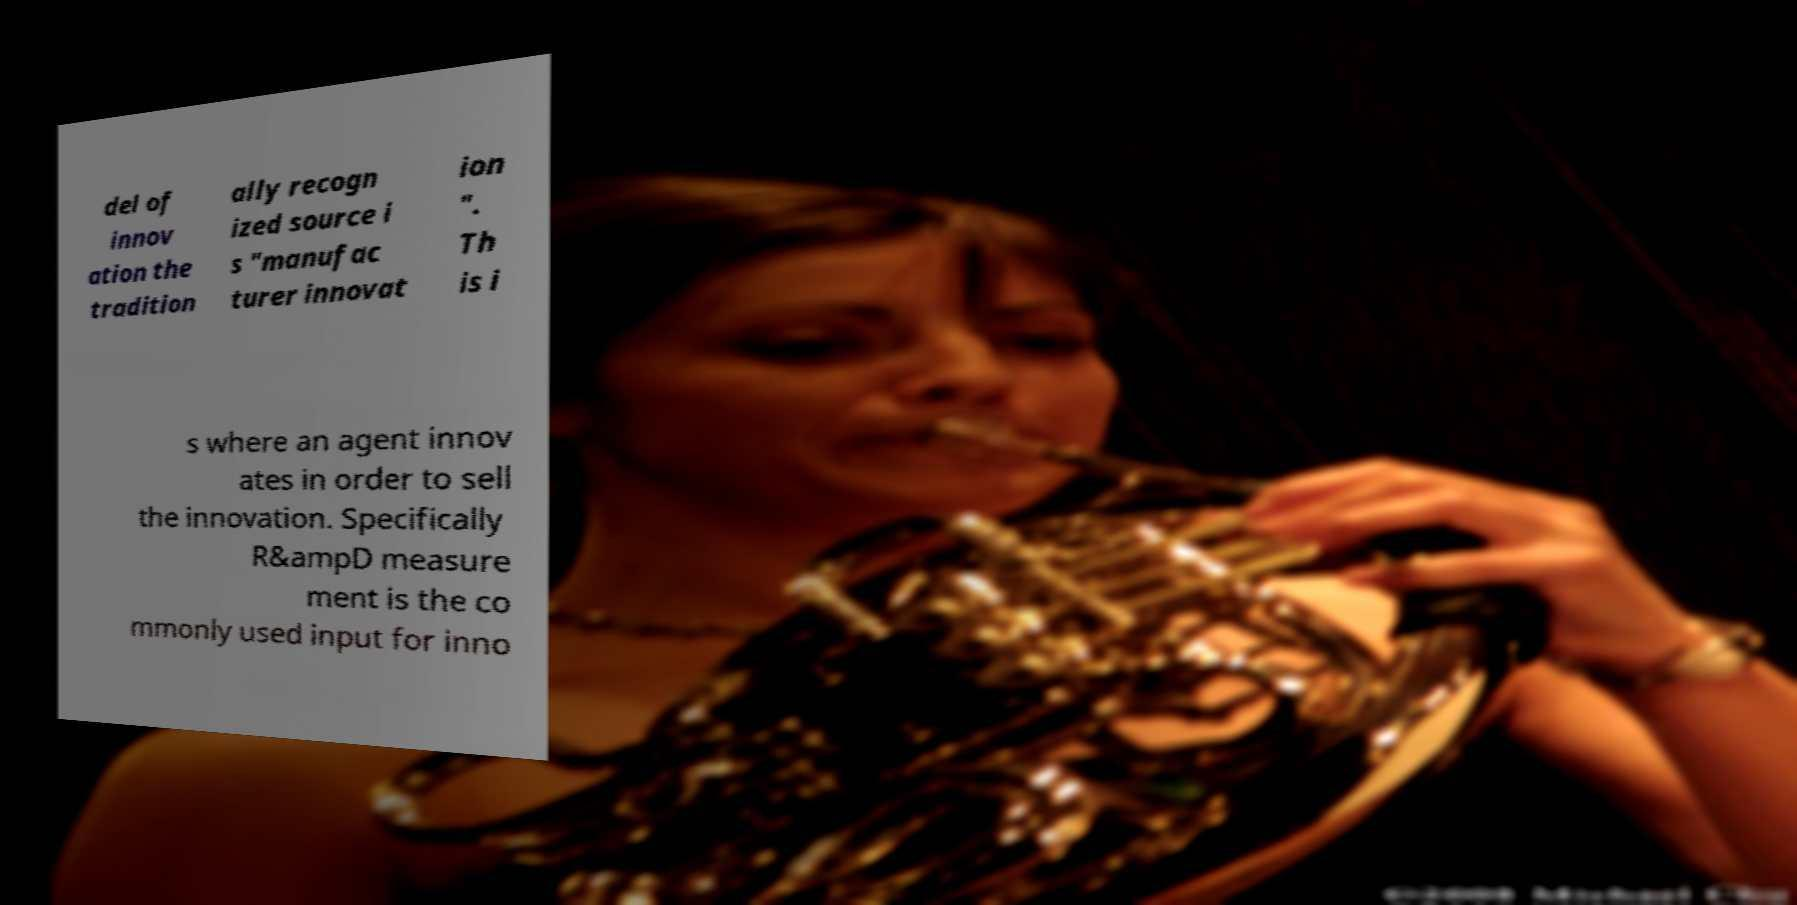I need the written content from this picture converted into text. Can you do that? del of innov ation the tradition ally recogn ized source i s "manufac turer innovat ion ". Th is i s where an agent innov ates in order to sell the innovation. Specifically R&ampD measure ment is the co mmonly used input for inno 